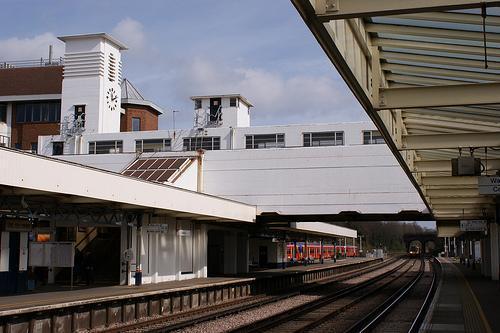How many trains are at the platform?
Give a very brief answer. 0. 